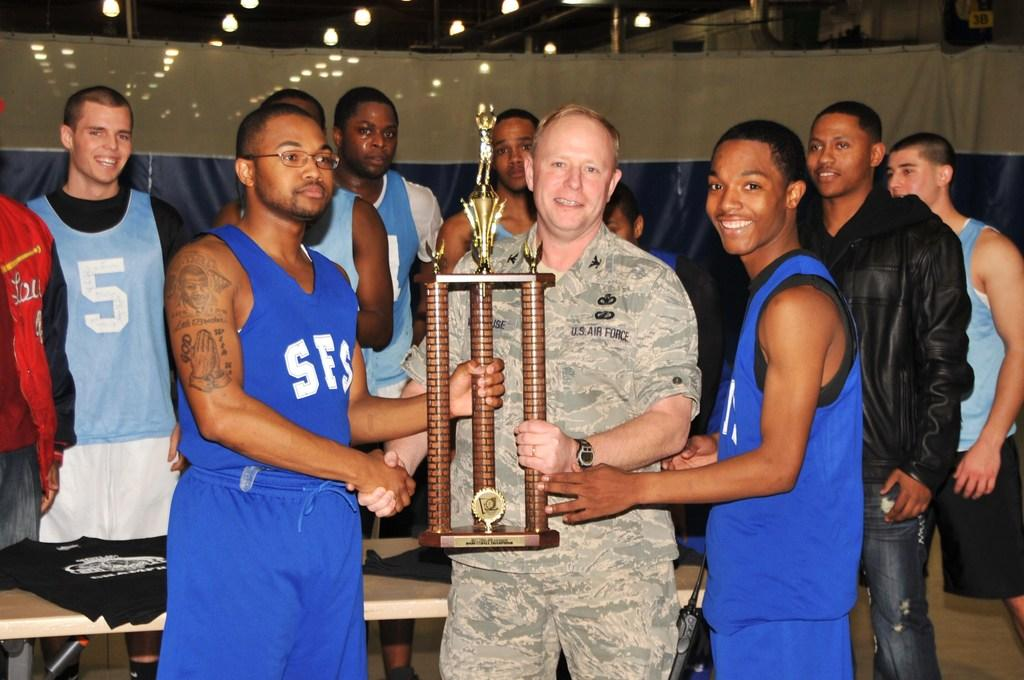<image>
Provide a brief description of the given image. A soldier in US Air Force fatigues holds a trophy as he's flanked by two players. 